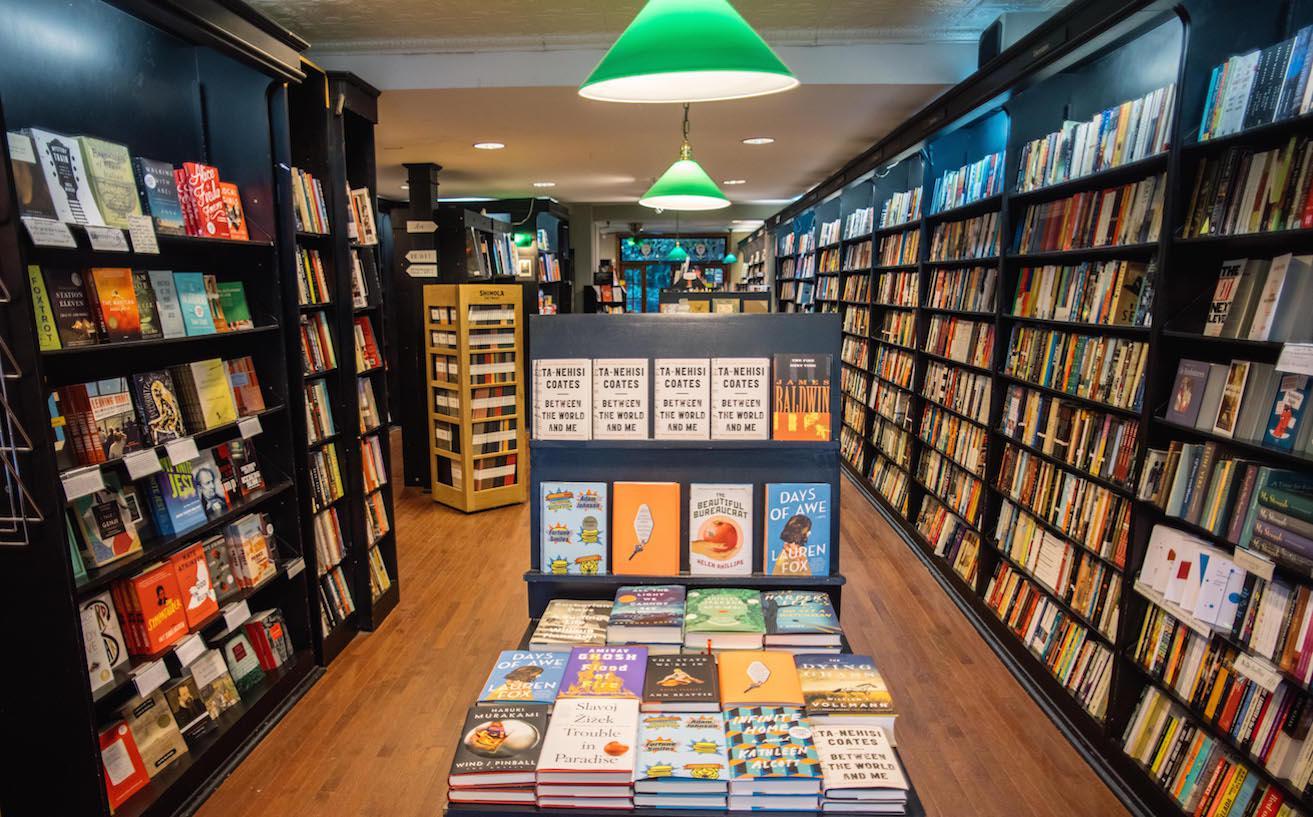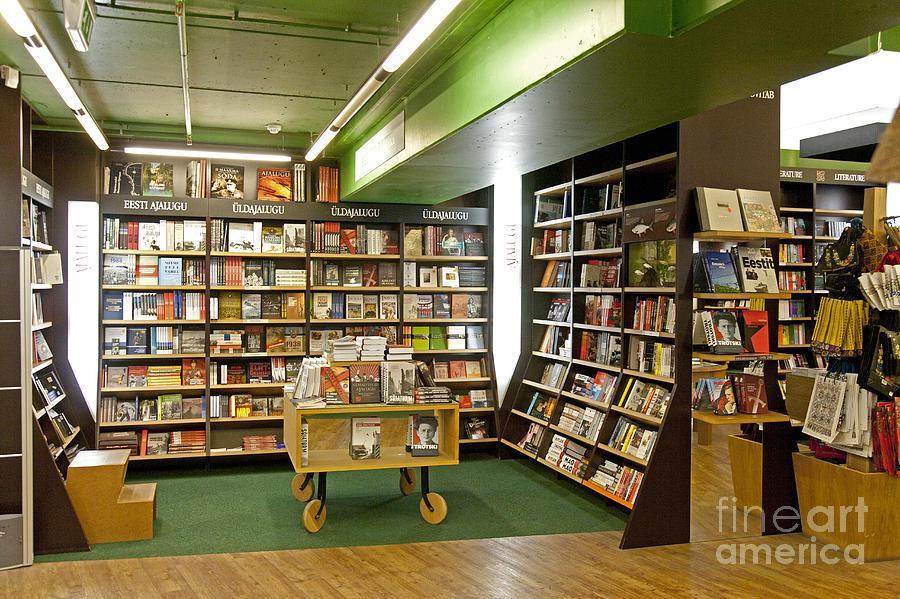The first image is the image on the left, the second image is the image on the right. Evaluate the accuracy of this statement regarding the images: "wooden french doors are open and visible from the inside of the store". Is it true? Answer yes or no. No. The first image is the image on the left, the second image is the image on the right. Considering the images on both sides, is "There is a stained glass window visible over the doorway." valid? Answer yes or no. No. 